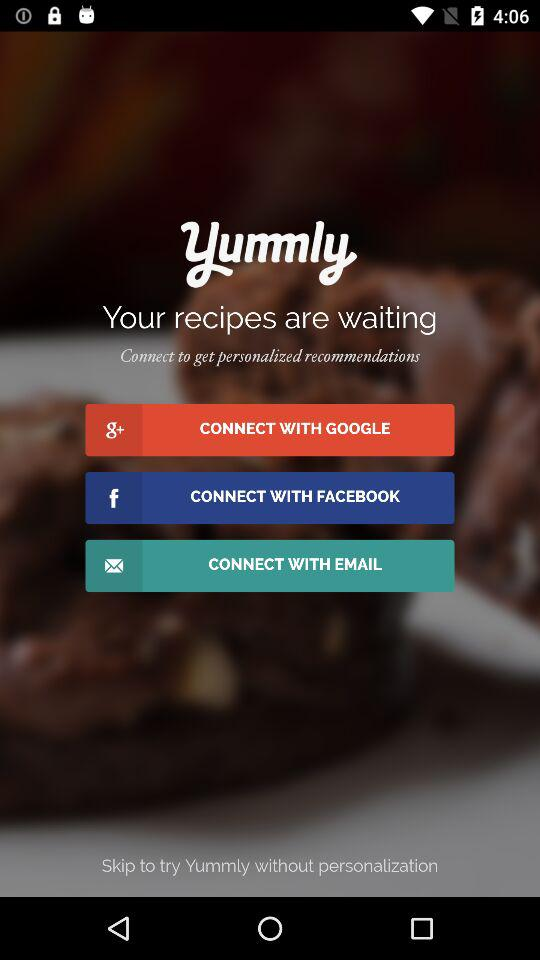Which applications can we connect with? You can connect with "GOOGLE" and "FACEBOOK" applications. 